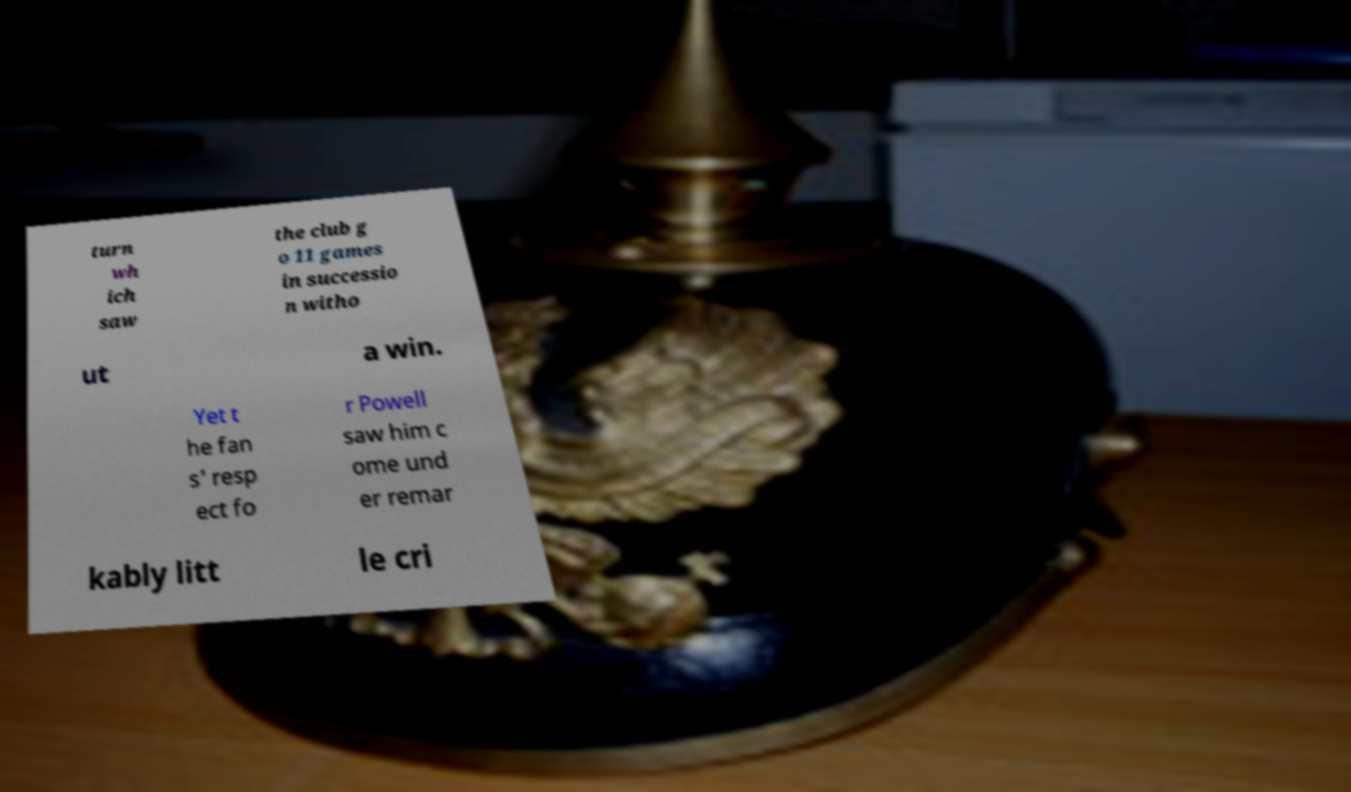Please identify and transcribe the text found in this image. turn wh ich saw the club g o 11 games in successio n witho ut a win. Yet t he fan s' resp ect fo r Powell saw him c ome und er remar kably litt le cri 